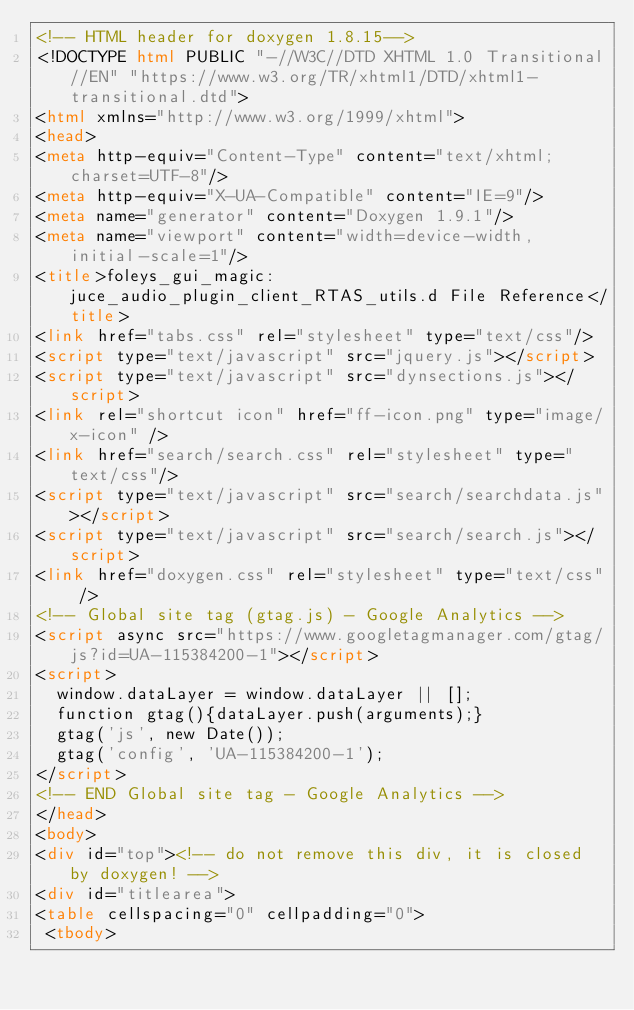Convert code to text. <code><loc_0><loc_0><loc_500><loc_500><_HTML_><!-- HTML header for doxygen 1.8.15-->
<!DOCTYPE html PUBLIC "-//W3C//DTD XHTML 1.0 Transitional//EN" "https://www.w3.org/TR/xhtml1/DTD/xhtml1-transitional.dtd">
<html xmlns="http://www.w3.org/1999/xhtml">
<head>
<meta http-equiv="Content-Type" content="text/xhtml;charset=UTF-8"/>
<meta http-equiv="X-UA-Compatible" content="IE=9"/>
<meta name="generator" content="Doxygen 1.9.1"/>
<meta name="viewport" content="width=device-width, initial-scale=1"/>
<title>foleys_gui_magic: juce_audio_plugin_client_RTAS_utils.d File Reference</title>
<link href="tabs.css" rel="stylesheet" type="text/css"/>
<script type="text/javascript" src="jquery.js"></script>
<script type="text/javascript" src="dynsections.js"></script>
<link rel="shortcut icon" href="ff-icon.png" type="image/x-icon" />
<link href="search/search.css" rel="stylesheet" type="text/css"/>
<script type="text/javascript" src="search/searchdata.js"></script>
<script type="text/javascript" src="search/search.js"></script>
<link href="doxygen.css" rel="stylesheet" type="text/css" />
<!-- Global site tag (gtag.js) - Google Analytics -->
<script async src="https://www.googletagmanager.com/gtag/js?id=UA-115384200-1"></script>
<script>
  window.dataLayer = window.dataLayer || [];
  function gtag(){dataLayer.push(arguments);}
  gtag('js', new Date());
  gtag('config', 'UA-115384200-1');
</script>
<!-- END Global site tag - Google Analytics -->
</head>
<body>
<div id="top"><!-- do not remove this div, it is closed by doxygen! -->
<div id="titlearea">
<table cellspacing="0" cellpadding="0">
 <tbody></code> 